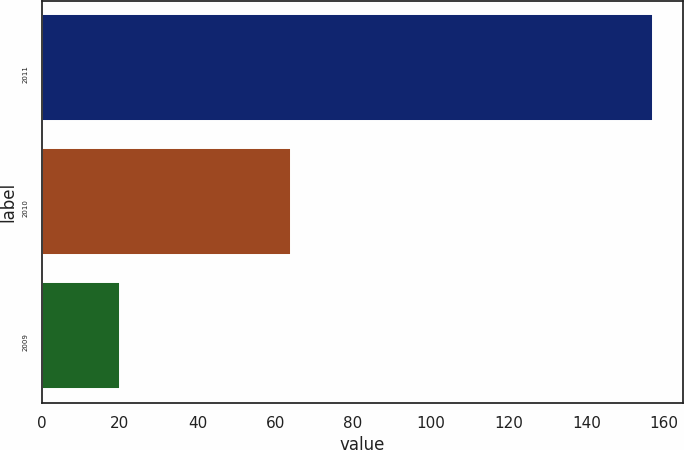Convert chart to OTSL. <chart><loc_0><loc_0><loc_500><loc_500><bar_chart><fcel>2011<fcel>2010<fcel>2009<nl><fcel>157<fcel>64<fcel>20<nl></chart> 